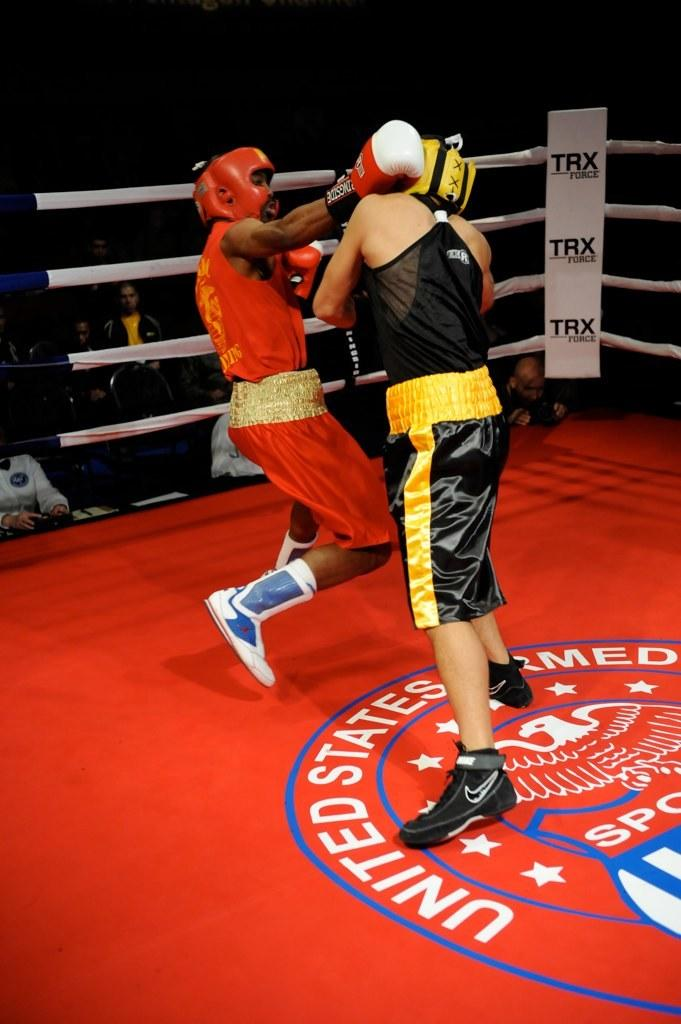Provide a one-sentence caption for the provided image. two boxers going at it in red ring that has united states armed forces sports emblem. 